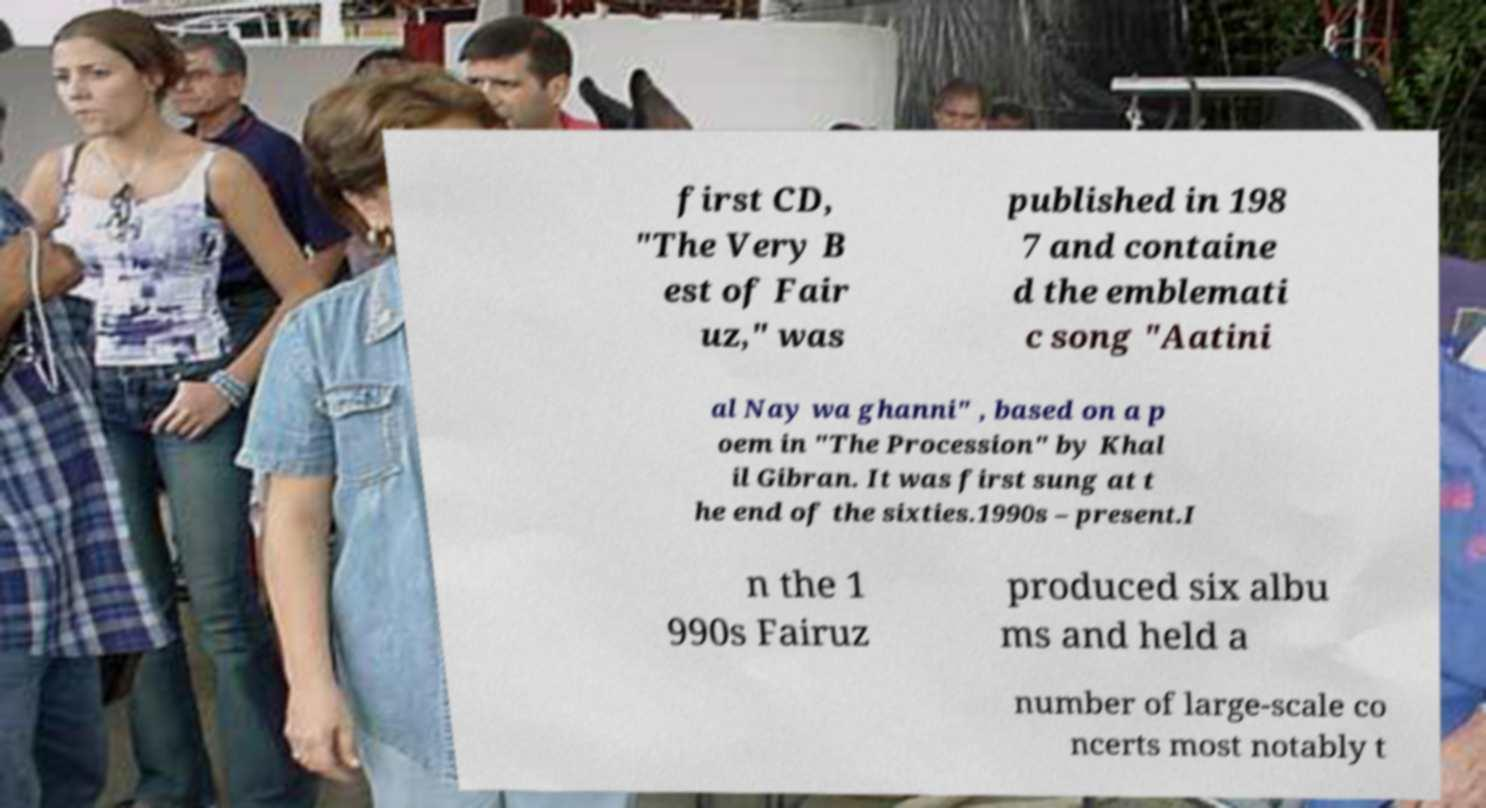Please read and relay the text visible in this image. What does it say? first CD, "The Very B est of Fair uz," was published in 198 7 and containe d the emblemati c song "Aatini al Nay wa ghanni" , based on a p oem in "The Procession" by Khal il Gibran. It was first sung at t he end of the sixties.1990s – present.I n the 1 990s Fairuz produced six albu ms and held a number of large-scale co ncerts most notably t 